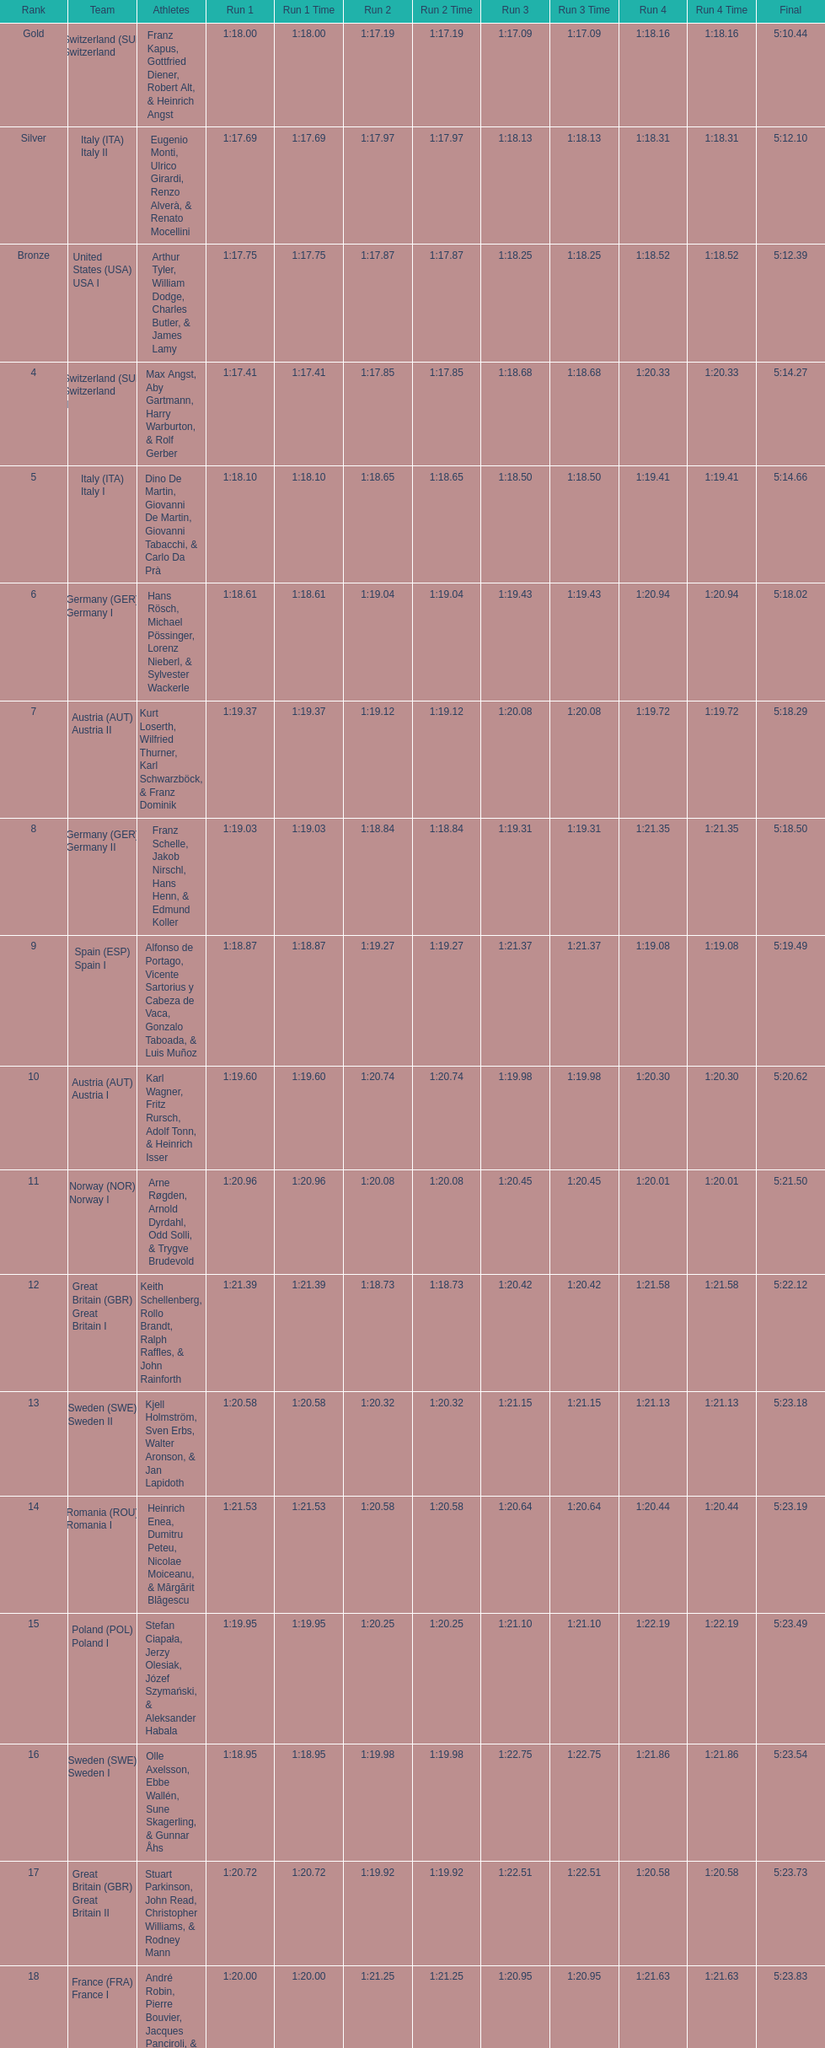I'm looking to parse the entire table for insights. Could you assist me with that? {'header': ['Rank', 'Team', 'Athletes', 'Run 1', 'Run 1 Time', 'Run 2', 'Run 2 Time', 'Run 3', 'Run 3 Time', 'Run 4', 'Run 4 Time', 'Final'], 'rows': [['Gold', 'Switzerland\xa0(SUI) Switzerland I', 'Franz Kapus, Gottfried Diener, Robert Alt, & Heinrich Angst', '1:18.00', '1:18.00', '1:17.19', '1:17.19', '1:17.09', '1:17.09', '1:18.16', '1:18.16', '5:10.44'], ['Silver', 'Italy\xa0(ITA) Italy II', 'Eugenio Monti, Ulrico Girardi, Renzo Alverà, & Renato Mocellini', '1:17.69', '1:17.69', '1:17.97', '1:17.97', '1:18.13', '1:18.13', '1:18.31', '1:18.31', '5:12.10'], ['Bronze', 'United States\xa0(USA) USA I', 'Arthur Tyler, William Dodge, Charles Butler, & James Lamy', '1:17.75', '1:17.75', '1:17.87', '1:17.87', '1:18.25', '1:18.25', '1:18.52', '1:18.52', '5:12.39'], ['4', 'Switzerland\xa0(SUI) Switzerland II', 'Max Angst, Aby Gartmann, Harry Warburton, & Rolf Gerber', '1:17.41', '1:17.41', '1:17.85', '1:17.85', '1:18.68', '1:18.68', '1:20.33', '1:20.33', '5:14.27'], ['5', 'Italy\xa0(ITA) Italy I', 'Dino De Martin, Giovanni De Martin, Giovanni Tabacchi, & Carlo Da Prà', '1:18.10', '1:18.10', '1:18.65', '1:18.65', '1:18.50', '1:18.50', '1:19.41', '1:19.41', '5:14.66'], ['6', 'Germany\xa0(GER) Germany I', 'Hans Rösch, Michael Pössinger, Lorenz Nieberl, & Sylvester Wackerle', '1:18.61', '1:18.61', '1:19.04', '1:19.04', '1:19.43', '1:19.43', '1:20.94', '1:20.94', '5:18.02'], ['7', 'Austria\xa0(AUT) Austria II', 'Kurt Loserth, Wilfried Thurner, Karl Schwarzböck, & Franz Dominik', '1:19.37', '1:19.37', '1:19.12', '1:19.12', '1:20.08', '1:20.08', '1:19.72', '1:19.72', '5:18.29'], ['8', 'Germany\xa0(GER) Germany II', 'Franz Schelle, Jakob Nirschl, Hans Henn, & Edmund Koller', '1:19.03', '1:19.03', '1:18.84', '1:18.84', '1:19.31', '1:19.31', '1:21.35', '1:21.35', '5:18.50'], ['9', 'Spain\xa0(ESP) Spain I', 'Alfonso de Portago, Vicente Sartorius y Cabeza de Vaca, Gonzalo Taboada, & Luis Muñoz', '1:18.87', '1:18.87', '1:19.27', '1:19.27', '1:21.37', '1:21.37', '1:19.08', '1:19.08', '5:19.49'], ['10', 'Austria\xa0(AUT) Austria I', 'Karl Wagner, Fritz Rursch, Adolf Tonn, & Heinrich Isser', '1:19.60', '1:19.60', '1:20.74', '1:20.74', '1:19.98', '1:19.98', '1:20.30', '1:20.30', '5:20.62'], ['11', 'Norway\xa0(NOR) Norway I', 'Arne Røgden, Arnold Dyrdahl, Odd Solli, & Trygve Brudevold', '1:20.96', '1:20.96', '1:20.08', '1:20.08', '1:20.45', '1:20.45', '1:20.01', '1:20.01', '5:21.50'], ['12', 'Great Britain\xa0(GBR) Great Britain I', 'Keith Schellenberg, Rollo Brandt, Ralph Raffles, & John Rainforth', '1:21.39', '1:21.39', '1:18.73', '1:18.73', '1:20.42', '1:20.42', '1:21.58', '1:21.58', '5:22.12'], ['13', 'Sweden\xa0(SWE) Sweden II', 'Kjell Holmström, Sven Erbs, Walter Aronson, & Jan Lapidoth', '1:20.58', '1:20.58', '1:20.32', '1:20.32', '1:21.15', '1:21.15', '1:21.13', '1:21.13', '5:23.18'], ['14', 'Romania\xa0(ROU) Romania I', 'Heinrich Enea, Dumitru Peteu, Nicolae Moiceanu, & Mărgărit Blăgescu', '1:21.53', '1:21.53', '1:20.58', '1:20.58', '1:20.64', '1:20.64', '1:20.44', '1:20.44', '5:23.19'], ['15', 'Poland\xa0(POL) Poland I', 'Stefan Ciapała, Jerzy Olesiak, Józef Szymański, & Aleksander Habala', '1:19.95', '1:19.95', '1:20.25', '1:20.25', '1:21.10', '1:21.10', '1:22.19', '1:22.19', '5:23.49'], ['16', 'Sweden\xa0(SWE) Sweden I', 'Olle Axelsson, Ebbe Wallén, Sune Skagerling, & Gunnar Åhs', '1:18.95', '1:18.95', '1:19.98', '1:19.98', '1:22.75', '1:22.75', '1:21.86', '1:21.86', '5:23.54'], ['17', 'Great Britain\xa0(GBR) Great Britain II', 'Stuart Parkinson, John Read, Christopher Williams, & Rodney Mann', '1:20.72', '1:20.72', '1:19.92', '1:19.92', '1:22.51', '1:22.51', '1:20.58', '1:20.58', '5:23.73'], ['18', 'France\xa0(FRA) France I', 'André Robin, Pierre Bouvier, Jacques Panciroli, & Lucien Grosso', '1:20.00', '1:20.00', '1:21.25', '1:21.25', '1:20.95', '1:20.95', '1:21.63', '1:21.63', '5:23.83'], ['19', 'United States\xa0(USA) USA II', 'James Bickford, Donald Jacques, Lawrence McKillip, & Hubert Miller', '1:20.97', '1:20.97', '1:22.47', '1:22.47', '1:21.22', '1:21.22', '1:20.50', '1:20.50', '5:25.16'], ['20', 'Romania\xa0(ROU) Romania II', 'Constantin Dragomir, Vasile Panait, Ion Staicu, & Gheorghe Moldoveanu', '1:21.21', '1:21.21', '1:21.22', '1:21.22', '1:22.37', '1:22.37', '1:23.03', '1:23.03', '5:27.83'], ['21', 'Poland\xa0(POL) Poland II', 'Aleksy Konieczny, Zygmunt Konieczny, Włodzimierz Źróbik, & Zbigniew Skowroński/Jan Dąbrowski(*)', '', '-', '', '-', '', '-', '', '-', '5:28.40']]} Who placed the highest, italy or germany? Italy. 